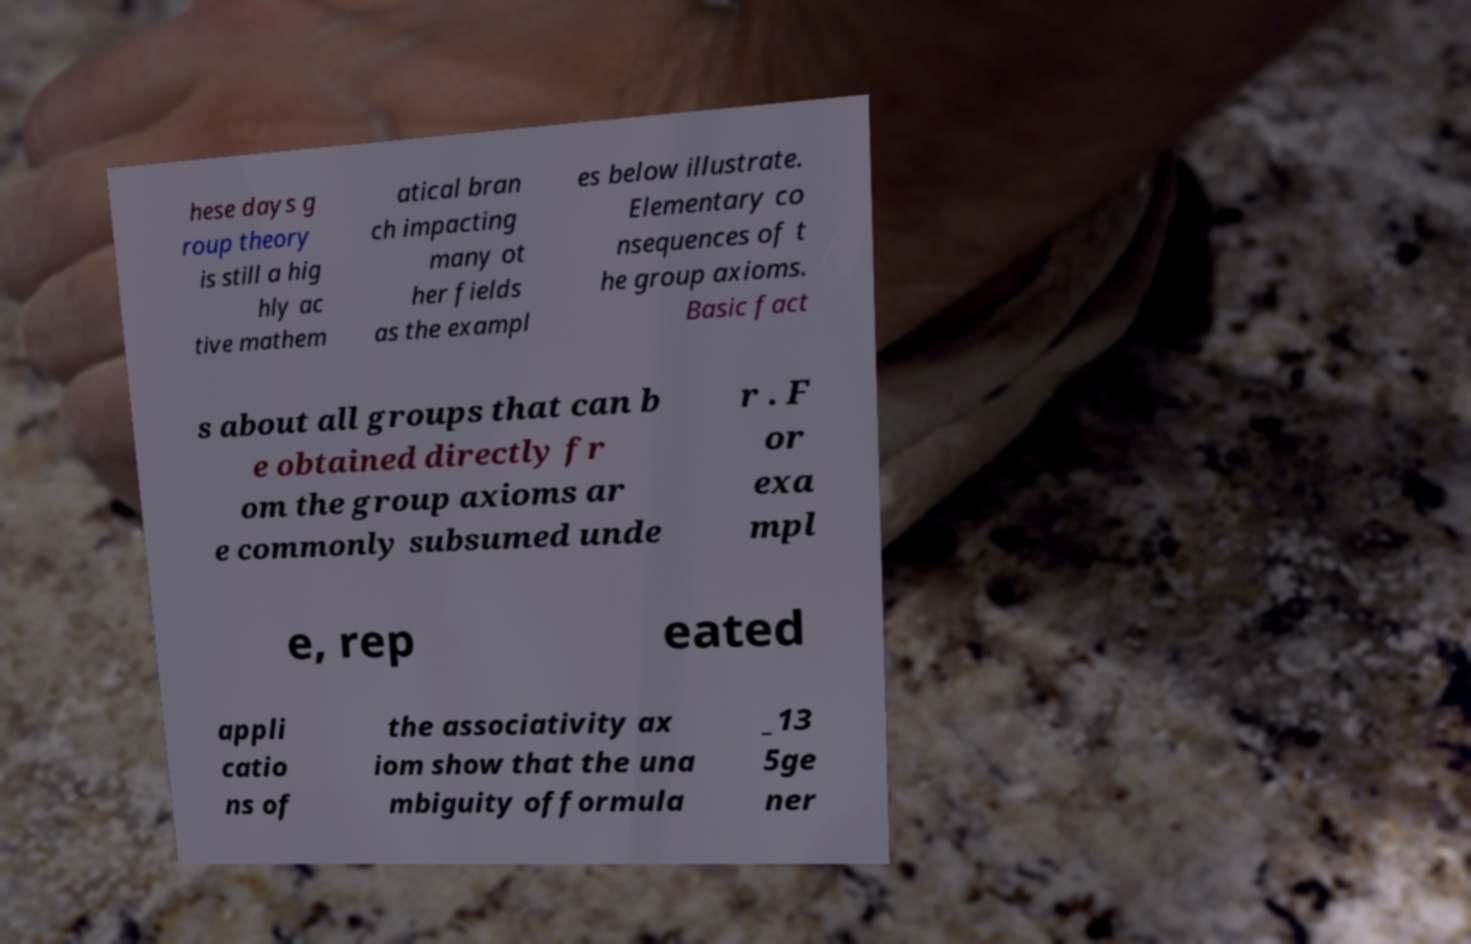Could you assist in decoding the text presented in this image and type it out clearly? hese days g roup theory is still a hig hly ac tive mathem atical bran ch impacting many ot her fields as the exampl es below illustrate. Elementary co nsequences of t he group axioms. Basic fact s about all groups that can b e obtained directly fr om the group axioms ar e commonly subsumed unde r . F or exa mpl e, rep eated appli catio ns of the associativity ax iom show that the una mbiguity offormula _13 5ge ner 